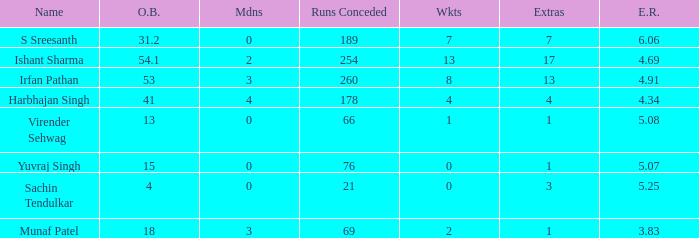Name the total number of wickets being yuvraj singh 1.0. 